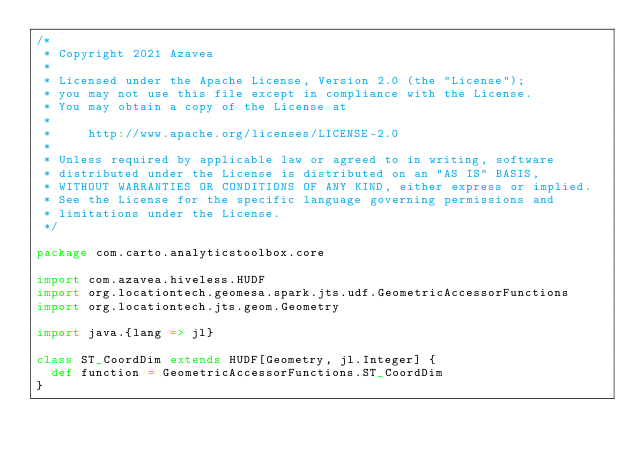<code> <loc_0><loc_0><loc_500><loc_500><_Scala_>/*
 * Copyright 2021 Azavea
 *
 * Licensed under the Apache License, Version 2.0 (the "License");
 * you may not use this file except in compliance with the License.
 * You may obtain a copy of the License at
 *
 *     http://www.apache.org/licenses/LICENSE-2.0
 *
 * Unless required by applicable law or agreed to in writing, software
 * distributed under the License is distributed on an "AS IS" BASIS,
 * WITHOUT WARRANTIES OR CONDITIONS OF ANY KIND, either express or implied.
 * See the License for the specific language governing permissions and
 * limitations under the License.
 */

package com.carto.analyticstoolbox.core

import com.azavea.hiveless.HUDF
import org.locationtech.geomesa.spark.jts.udf.GeometricAccessorFunctions
import org.locationtech.jts.geom.Geometry

import java.{lang => jl}

class ST_CoordDim extends HUDF[Geometry, jl.Integer] {
  def function = GeometricAccessorFunctions.ST_CoordDim
}
</code> 